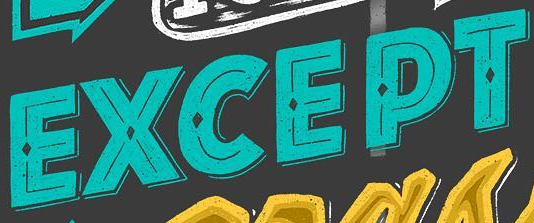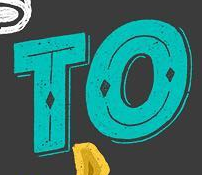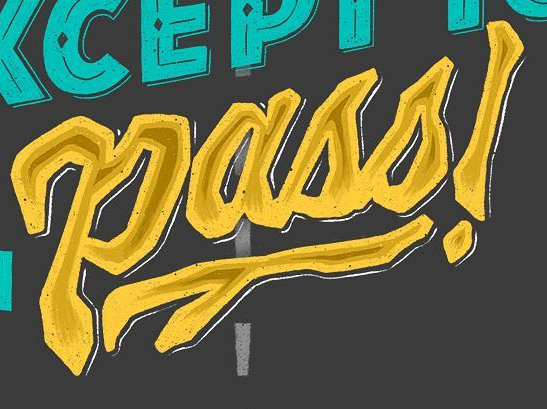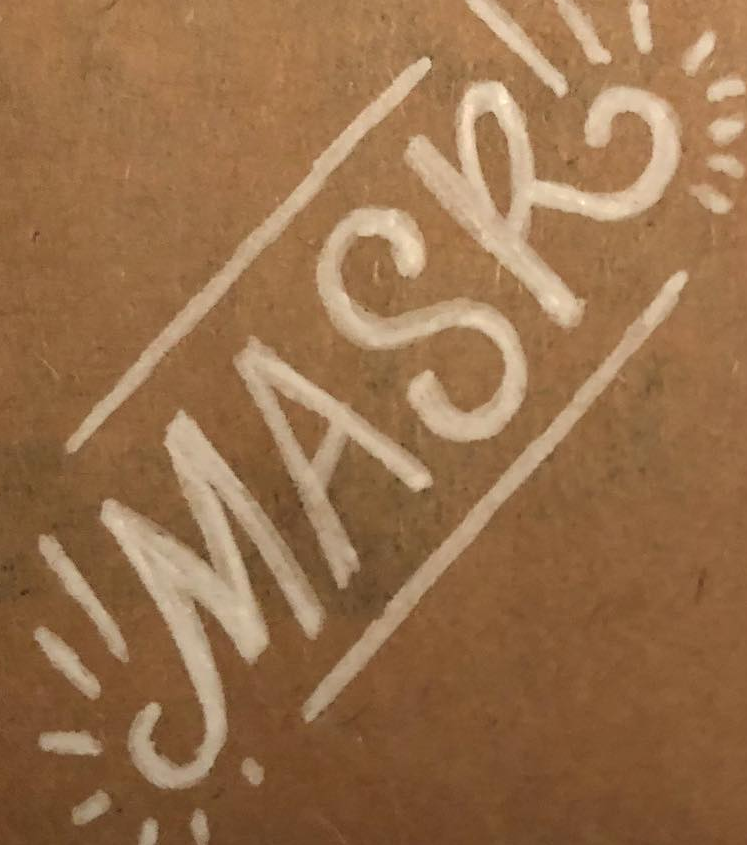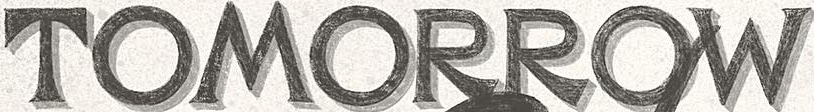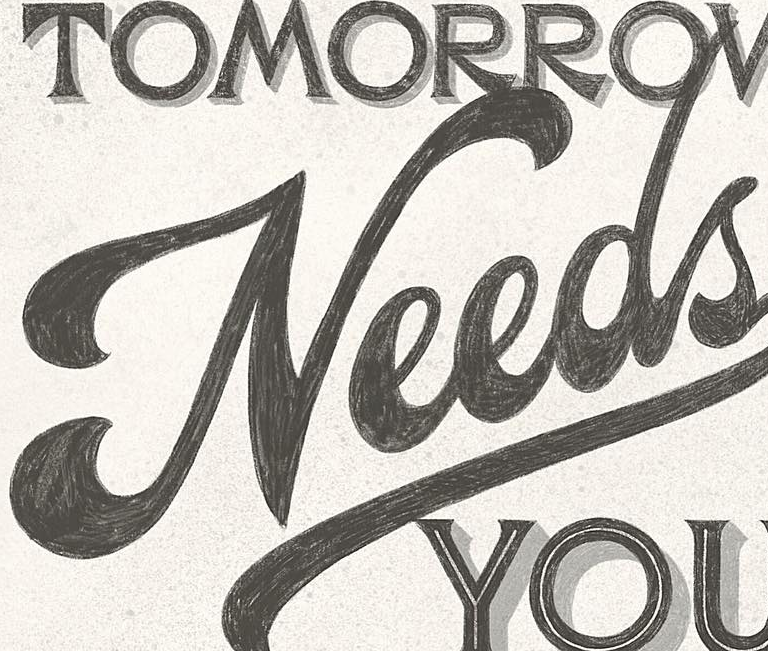What words are shown in these images in order, separated by a semicolon? EXCEPT; TO; Pass!; MASK; TOMORROW; Needs 